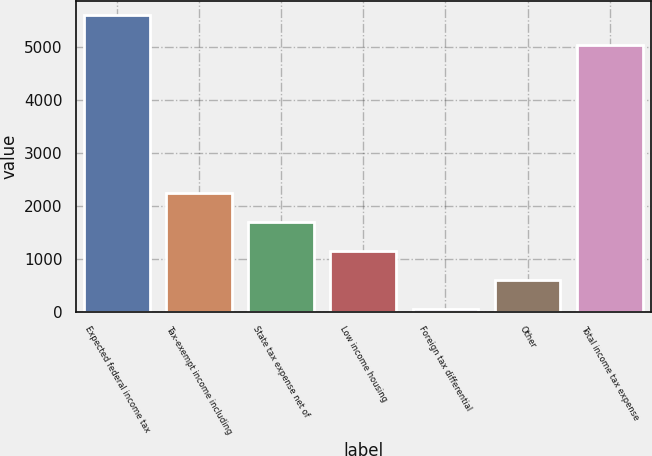Convert chart. <chart><loc_0><loc_0><loc_500><loc_500><bar_chart><fcel>Expected federal income tax<fcel>Tax-exempt income including<fcel>State tax expense net of<fcel>Low income housing<fcel>Foreign tax differential<fcel>Other<fcel>Total income tax expense<nl><fcel>5601.1<fcel>2250.4<fcel>1700.3<fcel>1150.2<fcel>50<fcel>600.1<fcel>5051<nl></chart> 